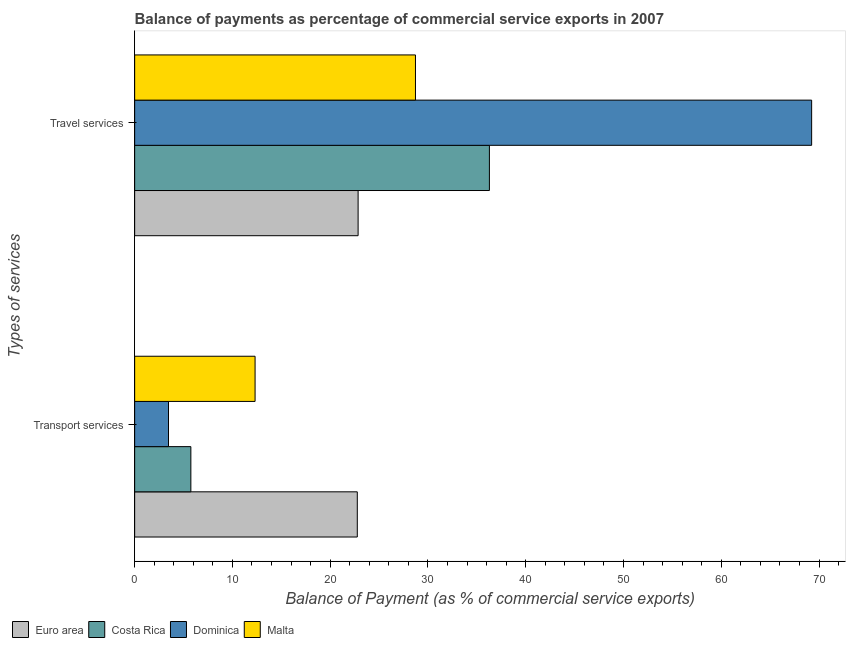What is the label of the 2nd group of bars from the top?
Ensure brevity in your answer.  Transport services. What is the balance of payments of travel services in Euro area?
Provide a short and direct response. 22.86. Across all countries, what is the maximum balance of payments of transport services?
Ensure brevity in your answer.  22.77. Across all countries, what is the minimum balance of payments of transport services?
Make the answer very short. 3.46. In which country was the balance of payments of travel services maximum?
Give a very brief answer. Dominica. In which country was the balance of payments of transport services minimum?
Your answer should be compact. Dominica. What is the total balance of payments of transport services in the graph?
Provide a succinct answer. 44.3. What is the difference between the balance of payments of travel services in Euro area and that in Malta?
Provide a succinct answer. -5.87. What is the difference between the balance of payments of transport services in Malta and the balance of payments of travel services in Dominica?
Your answer should be very brief. -56.92. What is the average balance of payments of transport services per country?
Ensure brevity in your answer.  11.07. What is the difference between the balance of payments of transport services and balance of payments of travel services in Dominica?
Make the answer very short. -65.78. In how many countries, is the balance of payments of transport services greater than 70 %?
Your response must be concise. 0. What is the ratio of the balance of payments of transport services in Euro area to that in Malta?
Provide a short and direct response. 1.85. Is the balance of payments of transport services in Dominica less than that in Euro area?
Offer a very short reply. Yes. What does the 1st bar from the top in Transport services represents?
Your answer should be compact. Malta. What does the 2nd bar from the bottom in Transport services represents?
Keep it short and to the point. Costa Rica. How many countries are there in the graph?
Your answer should be very brief. 4. How many legend labels are there?
Your answer should be very brief. 4. How are the legend labels stacked?
Offer a terse response. Horizontal. What is the title of the graph?
Your answer should be compact. Balance of payments as percentage of commercial service exports in 2007. Does "Norway" appear as one of the legend labels in the graph?
Ensure brevity in your answer.  No. What is the label or title of the X-axis?
Offer a terse response. Balance of Payment (as % of commercial service exports). What is the label or title of the Y-axis?
Make the answer very short. Types of services. What is the Balance of Payment (as % of commercial service exports) of Euro area in Transport services?
Ensure brevity in your answer.  22.77. What is the Balance of Payment (as % of commercial service exports) of Costa Rica in Transport services?
Make the answer very short. 5.75. What is the Balance of Payment (as % of commercial service exports) in Dominica in Transport services?
Your answer should be very brief. 3.46. What is the Balance of Payment (as % of commercial service exports) in Malta in Transport services?
Provide a succinct answer. 12.32. What is the Balance of Payment (as % of commercial service exports) of Euro area in Travel services?
Give a very brief answer. 22.86. What is the Balance of Payment (as % of commercial service exports) of Costa Rica in Travel services?
Offer a terse response. 36.28. What is the Balance of Payment (as % of commercial service exports) of Dominica in Travel services?
Offer a terse response. 69.24. What is the Balance of Payment (as % of commercial service exports) in Malta in Travel services?
Provide a succinct answer. 28.72. Across all Types of services, what is the maximum Balance of Payment (as % of commercial service exports) in Euro area?
Offer a very short reply. 22.86. Across all Types of services, what is the maximum Balance of Payment (as % of commercial service exports) in Costa Rica?
Keep it short and to the point. 36.28. Across all Types of services, what is the maximum Balance of Payment (as % of commercial service exports) in Dominica?
Give a very brief answer. 69.24. Across all Types of services, what is the maximum Balance of Payment (as % of commercial service exports) in Malta?
Provide a succinct answer. 28.72. Across all Types of services, what is the minimum Balance of Payment (as % of commercial service exports) of Euro area?
Keep it short and to the point. 22.77. Across all Types of services, what is the minimum Balance of Payment (as % of commercial service exports) in Costa Rica?
Your response must be concise. 5.75. Across all Types of services, what is the minimum Balance of Payment (as % of commercial service exports) of Dominica?
Your answer should be very brief. 3.46. Across all Types of services, what is the minimum Balance of Payment (as % of commercial service exports) of Malta?
Offer a terse response. 12.32. What is the total Balance of Payment (as % of commercial service exports) in Euro area in the graph?
Keep it short and to the point. 45.63. What is the total Balance of Payment (as % of commercial service exports) in Costa Rica in the graph?
Keep it short and to the point. 42.03. What is the total Balance of Payment (as % of commercial service exports) in Dominica in the graph?
Make the answer very short. 72.7. What is the total Balance of Payment (as % of commercial service exports) of Malta in the graph?
Your answer should be very brief. 41.04. What is the difference between the Balance of Payment (as % of commercial service exports) of Euro area in Transport services and that in Travel services?
Make the answer very short. -0.08. What is the difference between the Balance of Payment (as % of commercial service exports) of Costa Rica in Transport services and that in Travel services?
Offer a terse response. -30.53. What is the difference between the Balance of Payment (as % of commercial service exports) in Dominica in Transport services and that in Travel services?
Offer a terse response. -65.78. What is the difference between the Balance of Payment (as % of commercial service exports) in Malta in Transport services and that in Travel services?
Offer a terse response. -16.4. What is the difference between the Balance of Payment (as % of commercial service exports) of Euro area in Transport services and the Balance of Payment (as % of commercial service exports) of Costa Rica in Travel services?
Offer a terse response. -13.51. What is the difference between the Balance of Payment (as % of commercial service exports) of Euro area in Transport services and the Balance of Payment (as % of commercial service exports) of Dominica in Travel services?
Your response must be concise. -46.47. What is the difference between the Balance of Payment (as % of commercial service exports) of Euro area in Transport services and the Balance of Payment (as % of commercial service exports) of Malta in Travel services?
Keep it short and to the point. -5.95. What is the difference between the Balance of Payment (as % of commercial service exports) of Costa Rica in Transport services and the Balance of Payment (as % of commercial service exports) of Dominica in Travel services?
Offer a terse response. -63.49. What is the difference between the Balance of Payment (as % of commercial service exports) in Costa Rica in Transport services and the Balance of Payment (as % of commercial service exports) in Malta in Travel services?
Your answer should be very brief. -22.97. What is the difference between the Balance of Payment (as % of commercial service exports) in Dominica in Transport services and the Balance of Payment (as % of commercial service exports) in Malta in Travel services?
Your answer should be compact. -25.26. What is the average Balance of Payment (as % of commercial service exports) of Euro area per Types of services?
Give a very brief answer. 22.81. What is the average Balance of Payment (as % of commercial service exports) in Costa Rica per Types of services?
Ensure brevity in your answer.  21.02. What is the average Balance of Payment (as % of commercial service exports) of Dominica per Types of services?
Offer a very short reply. 36.35. What is the average Balance of Payment (as % of commercial service exports) of Malta per Types of services?
Ensure brevity in your answer.  20.52. What is the difference between the Balance of Payment (as % of commercial service exports) of Euro area and Balance of Payment (as % of commercial service exports) of Costa Rica in Transport services?
Keep it short and to the point. 17.02. What is the difference between the Balance of Payment (as % of commercial service exports) in Euro area and Balance of Payment (as % of commercial service exports) in Dominica in Transport services?
Your answer should be very brief. 19.31. What is the difference between the Balance of Payment (as % of commercial service exports) of Euro area and Balance of Payment (as % of commercial service exports) of Malta in Transport services?
Provide a short and direct response. 10.45. What is the difference between the Balance of Payment (as % of commercial service exports) in Costa Rica and Balance of Payment (as % of commercial service exports) in Dominica in Transport services?
Offer a terse response. 2.29. What is the difference between the Balance of Payment (as % of commercial service exports) in Costa Rica and Balance of Payment (as % of commercial service exports) in Malta in Transport services?
Provide a short and direct response. -6.57. What is the difference between the Balance of Payment (as % of commercial service exports) in Dominica and Balance of Payment (as % of commercial service exports) in Malta in Transport services?
Keep it short and to the point. -8.86. What is the difference between the Balance of Payment (as % of commercial service exports) in Euro area and Balance of Payment (as % of commercial service exports) in Costa Rica in Travel services?
Your response must be concise. -13.43. What is the difference between the Balance of Payment (as % of commercial service exports) of Euro area and Balance of Payment (as % of commercial service exports) of Dominica in Travel services?
Make the answer very short. -46.39. What is the difference between the Balance of Payment (as % of commercial service exports) in Euro area and Balance of Payment (as % of commercial service exports) in Malta in Travel services?
Keep it short and to the point. -5.87. What is the difference between the Balance of Payment (as % of commercial service exports) of Costa Rica and Balance of Payment (as % of commercial service exports) of Dominica in Travel services?
Your answer should be compact. -32.96. What is the difference between the Balance of Payment (as % of commercial service exports) of Costa Rica and Balance of Payment (as % of commercial service exports) of Malta in Travel services?
Ensure brevity in your answer.  7.56. What is the difference between the Balance of Payment (as % of commercial service exports) of Dominica and Balance of Payment (as % of commercial service exports) of Malta in Travel services?
Your answer should be compact. 40.52. What is the ratio of the Balance of Payment (as % of commercial service exports) of Costa Rica in Transport services to that in Travel services?
Give a very brief answer. 0.16. What is the ratio of the Balance of Payment (as % of commercial service exports) in Dominica in Transport services to that in Travel services?
Keep it short and to the point. 0.05. What is the ratio of the Balance of Payment (as % of commercial service exports) of Malta in Transport services to that in Travel services?
Your answer should be compact. 0.43. What is the difference between the highest and the second highest Balance of Payment (as % of commercial service exports) in Euro area?
Provide a short and direct response. 0.08. What is the difference between the highest and the second highest Balance of Payment (as % of commercial service exports) in Costa Rica?
Your answer should be very brief. 30.53. What is the difference between the highest and the second highest Balance of Payment (as % of commercial service exports) in Dominica?
Your answer should be very brief. 65.78. What is the difference between the highest and the second highest Balance of Payment (as % of commercial service exports) of Malta?
Your response must be concise. 16.4. What is the difference between the highest and the lowest Balance of Payment (as % of commercial service exports) of Euro area?
Offer a very short reply. 0.08. What is the difference between the highest and the lowest Balance of Payment (as % of commercial service exports) in Costa Rica?
Make the answer very short. 30.53. What is the difference between the highest and the lowest Balance of Payment (as % of commercial service exports) of Dominica?
Provide a succinct answer. 65.78. What is the difference between the highest and the lowest Balance of Payment (as % of commercial service exports) in Malta?
Give a very brief answer. 16.4. 